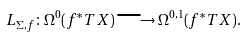Convert formula to latex. <formula><loc_0><loc_0><loc_500><loc_500>L _ { \Sigma , f } \colon \Omega ^ { 0 } ( f ^ { * } T X ) \longrightarrow \Omega ^ { 0 , 1 } ( f ^ { * } T X ) .</formula> 